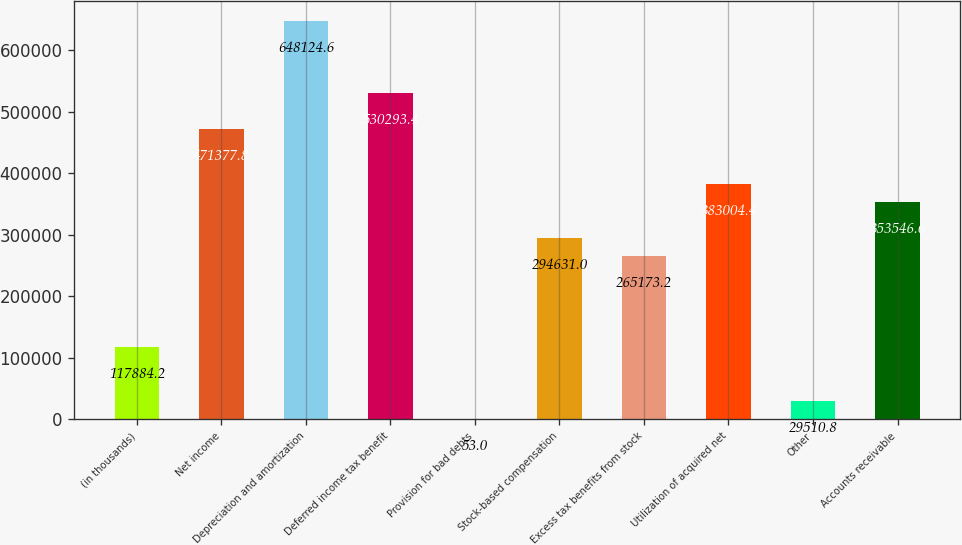Convert chart. <chart><loc_0><loc_0><loc_500><loc_500><bar_chart><fcel>(in thousands)<fcel>Net income<fcel>Depreciation and amortization<fcel>Deferred income tax benefit<fcel>Provision for bad debts<fcel>Stock-based compensation<fcel>Excess tax benefits from stock<fcel>Utilization of acquired net<fcel>Other<fcel>Accounts receivable<nl><fcel>117884<fcel>471378<fcel>648125<fcel>530293<fcel>53<fcel>294631<fcel>265173<fcel>383004<fcel>29510.8<fcel>353547<nl></chart> 